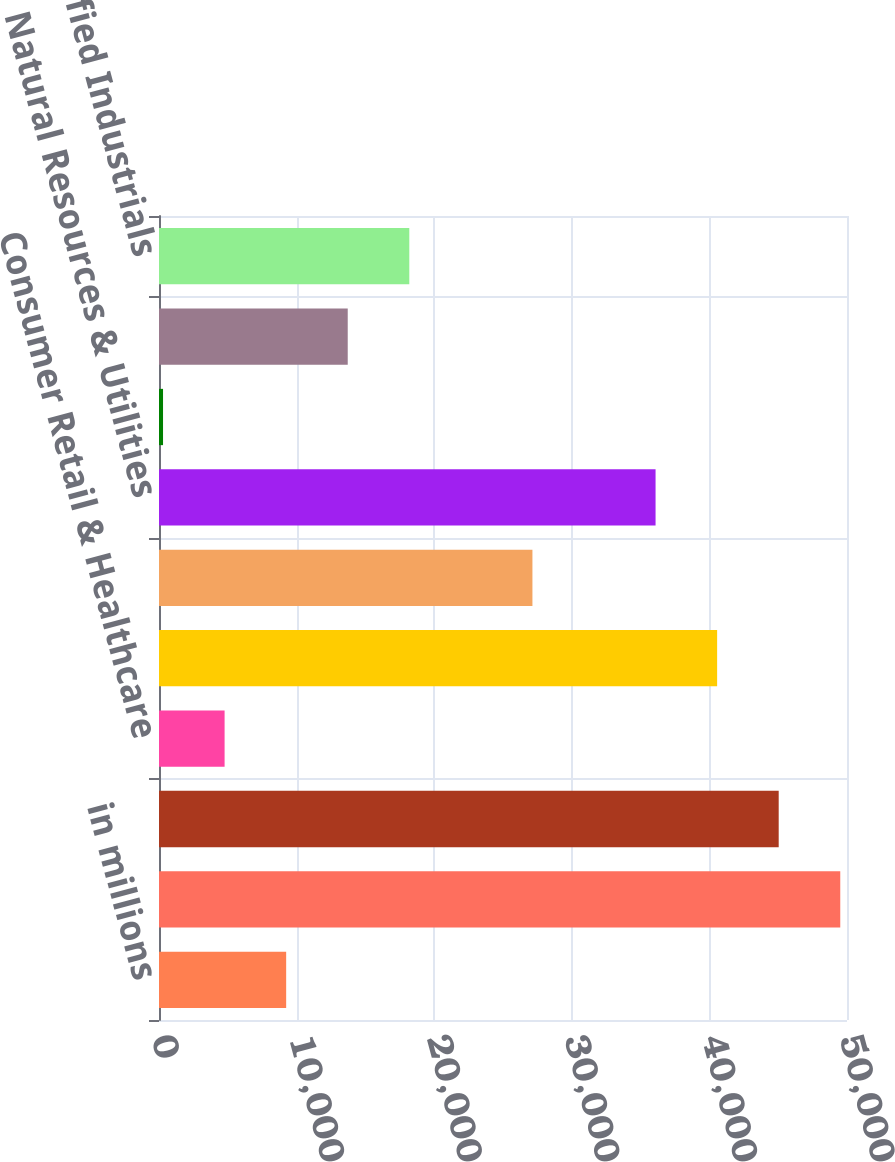Convert chart to OTSL. <chart><loc_0><loc_0><loc_500><loc_500><bar_chart><fcel>in millions<fcel>Funds<fcel>Financial Institutions<fcel>Consumer Retail & Healthcare<fcel>Sovereign<fcel>Municipalities & Nonprofit<fcel>Natural Resources & Utilities<fcel>Real Estate<fcel>Technology Media &<fcel>Diversified Industrials<nl><fcel>9241.6<fcel>49510.3<fcel>45036<fcel>4767.3<fcel>40561.7<fcel>27138.8<fcel>36087.4<fcel>293<fcel>13715.9<fcel>18190.2<nl></chart> 